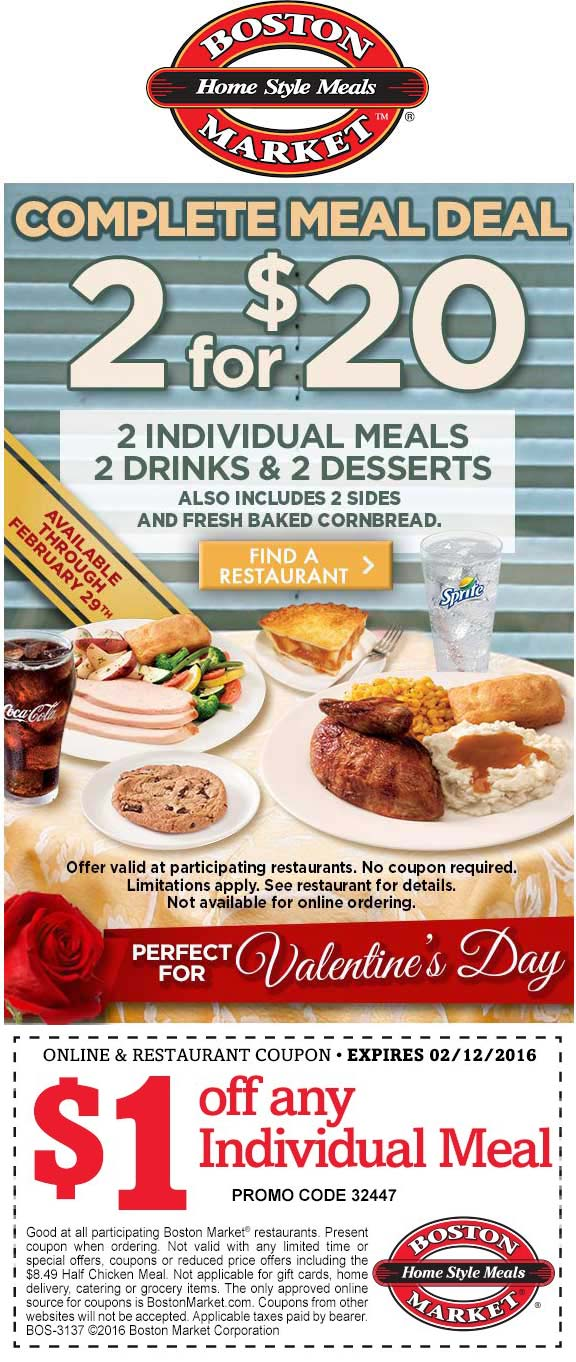What specific meals are included in the 'Complete Meal Deal', and what dietary options do they cater to? The 'Complete Meal Deal' includes two individual meals, each consisting of a main dish, two sides, and a dessert, complemented with two drinks. The advertisement showcases a variety of dishes such as roasted chicken, corn, stuffing, and freshly baked cornbread, catering to traditional dietary preferences. The presence of a soda and a slice of pie indicates additional options for dessert, although it may not cater specifically to distinct dietary restrictions like vegan or gluten-free unless mentioned elsewhere in their menu. 